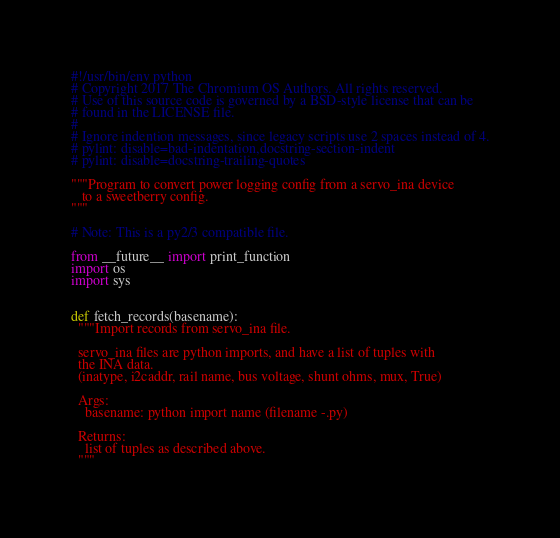Convert code to text. <code><loc_0><loc_0><loc_500><loc_500><_Python_>#!/usr/bin/env python
# Copyright 2017 The Chromium OS Authors. All rights reserved.
# Use of this source code is governed by a BSD-style license that can be
# found in the LICENSE file.
#
# Ignore indention messages, since legacy scripts use 2 spaces instead of 4.
# pylint: disable=bad-indentation,docstring-section-indent
# pylint: disable=docstring-trailing-quotes

"""Program to convert power logging config from a servo_ina device
   to a sweetberry config.
"""

# Note: This is a py2/3 compatible file.

from __future__ import print_function
import os
import sys


def fetch_records(basename):
  """Import records from servo_ina file.

  servo_ina files are python imports, and have a list of tuples with
  the INA data.
  (inatype, i2caddr, rail name, bus voltage, shunt ohms, mux, True)

  Args:
    basename: python import name (filename -.py)

  Returns:
    list of tuples as described above.
  """</code> 